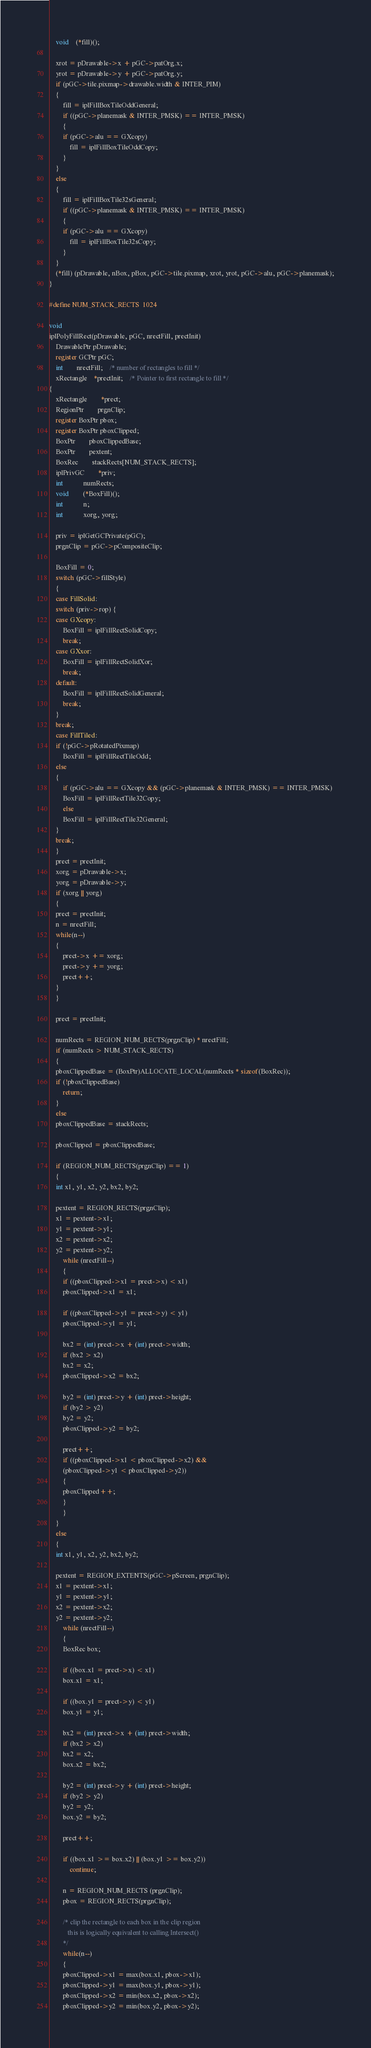<code> <loc_0><loc_0><loc_500><loc_500><_C_>    void    (*fill)();

    xrot = pDrawable->x + pGC->patOrg.x;
    yrot = pDrawable->y + pGC->patOrg.y;
    if (pGC->tile.pixmap->drawable.width & INTER_PIM)
    {
    	fill = iplFillBoxTileOddGeneral;
    	if ((pGC->planemask & INTER_PMSK) == INTER_PMSK)
    	{
	    if (pGC->alu == GXcopy)
	    	fill = iplFillBoxTileOddCopy;
    	}
    }
    else
    {
    	fill = iplFillBoxTile32sGeneral;
    	if ((pGC->planemask & INTER_PMSK) == INTER_PMSK)
    	{
	    if (pGC->alu == GXcopy)
	    	fill = iplFillBoxTile32sCopy;
    	}
    }
    (*fill) (pDrawable, nBox, pBox, pGC->tile.pixmap, xrot, yrot, pGC->alu, pGC->planemask);
}

#define NUM_STACK_RECTS	1024

void
iplPolyFillRect(pDrawable, pGC, nrectFill, prectInit)
    DrawablePtr pDrawable;
    register GCPtr pGC;
    int		nrectFill; 	/* number of rectangles to fill */
    xRectangle	*prectInit;  	/* Pointer to first rectangle to fill */
{
    xRectangle	    *prect;
    RegionPtr	    prgnClip;
    register BoxPtr pbox;
    register BoxPtr pboxClipped;
    BoxPtr	    pboxClippedBase;
    BoxPtr	    pextent;
    BoxRec	    stackRects[NUM_STACK_RECTS];
    iplPrivGC	    *priv;
    int		    numRects;
    void	    (*BoxFill)();
    int		    n;
    int		    xorg, yorg;

    priv = iplGetGCPrivate(pGC);
    prgnClip = pGC->pCompositeClip;

    BoxFill = 0;
    switch (pGC->fillStyle)
    {
    case FillSolid:
	switch (priv->rop) {
	case GXcopy:
	    BoxFill = iplFillRectSolidCopy;
	    break;
	case GXxor:
	    BoxFill = iplFillRectSolidXor;
	    break;
	default:
	    BoxFill = iplFillRectSolidGeneral;
	    break;
	}
	break;
    case FillTiled:
	if (!pGC->pRotatedPixmap)
	    BoxFill = iplFillRectTileOdd;
	else
	{
	    if (pGC->alu == GXcopy && (pGC->planemask & INTER_PMSK) == INTER_PMSK)
		BoxFill = iplFillRectTile32Copy;
	    else
		BoxFill = iplFillRectTile32General;
	}
	break;
    }
    prect = prectInit;
    xorg = pDrawable->x;
    yorg = pDrawable->y;
    if (xorg || yorg)
    {
	prect = prectInit;
	n = nrectFill;
	while(n--)
	{
	    prect->x += xorg;
	    prect->y += yorg;
	    prect++;
	}
    }

    prect = prectInit;

    numRects = REGION_NUM_RECTS(prgnClip) * nrectFill;
    if (numRects > NUM_STACK_RECTS)
    {
	pboxClippedBase = (BoxPtr)ALLOCATE_LOCAL(numRects * sizeof(BoxRec));
	if (!pboxClippedBase)
	    return;
    }
    else
	pboxClippedBase = stackRects;

    pboxClipped = pboxClippedBase;
	
    if (REGION_NUM_RECTS(prgnClip) == 1)
    {
	int x1, y1, x2, y2, bx2, by2;

	pextent = REGION_RECTS(prgnClip);
	x1 = pextent->x1;
	y1 = pextent->y1;
	x2 = pextent->x2;
	y2 = pextent->y2;
    	while (nrectFill--)
    	{
	    if ((pboxClipped->x1 = prect->x) < x1)
		pboxClipped->x1 = x1;
    
	    if ((pboxClipped->y1 = prect->y) < y1)
		pboxClipped->y1 = y1;
    
	    bx2 = (int) prect->x + (int) prect->width;
	    if (bx2 > x2)
		bx2 = x2;
	    pboxClipped->x2 = bx2;
    
	    by2 = (int) prect->y + (int) prect->height;
	    if (by2 > y2)
		by2 = y2;
	    pboxClipped->y2 = by2;

	    prect++;
	    if ((pboxClipped->x1 < pboxClipped->x2) &&
		(pboxClipped->y1 < pboxClipped->y2))
	    {
		pboxClipped++;
	    }
    	}
    }
    else
    {
	int x1, y1, x2, y2, bx2, by2;

	pextent = REGION_EXTENTS(pGC->pScreen, prgnClip);
	x1 = pextent->x1;
	y1 = pextent->y1;
	x2 = pextent->x2;
	y2 = pextent->y2;
    	while (nrectFill--)
    	{
	    BoxRec box;
    
	    if ((box.x1 = prect->x) < x1)
		box.x1 = x1;
    
	    if ((box.y1 = prect->y) < y1)
		box.y1 = y1;
    
	    bx2 = (int) prect->x + (int) prect->width;
	    if (bx2 > x2)
		bx2 = x2;
	    box.x2 = bx2;
    
	    by2 = (int) prect->y + (int) prect->height;
	    if (by2 > y2)
		by2 = y2;
	    box.y2 = by2;
    
	    prect++;
    
	    if ((box.x1 >= box.x2) || (box.y1 >= box.y2))
	    	continue;
    
	    n = REGION_NUM_RECTS (prgnClip);
	    pbox = REGION_RECTS(prgnClip);
    
	    /* clip the rectangle to each box in the clip region
	       this is logically equivalent to calling Intersect()
	    */
	    while(n--)
	    {
		pboxClipped->x1 = max(box.x1, pbox->x1);
		pboxClipped->y1 = max(box.y1, pbox->y1);
		pboxClipped->x2 = min(box.x2, pbox->x2);
		pboxClipped->y2 = min(box.y2, pbox->y2);</code> 